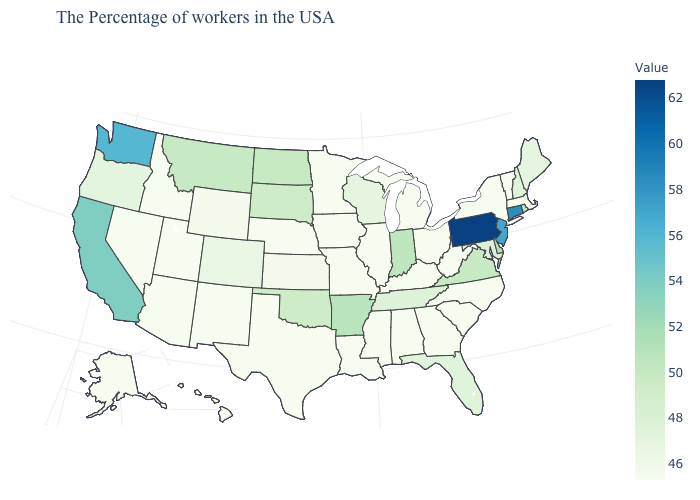Which states have the lowest value in the USA?
Be succinct. Massachusetts, Vermont, New York, North Carolina, South Carolina, West Virginia, Ohio, Georgia, Michigan, Kentucky, Alabama, Illinois, Mississippi, Louisiana, Missouri, Minnesota, Iowa, Nebraska, Texas, New Mexico, Utah, Arizona, Idaho, Nevada, Alaska, Hawaii. Which states have the lowest value in the Northeast?
Concise answer only. Massachusetts, Vermont, New York. 